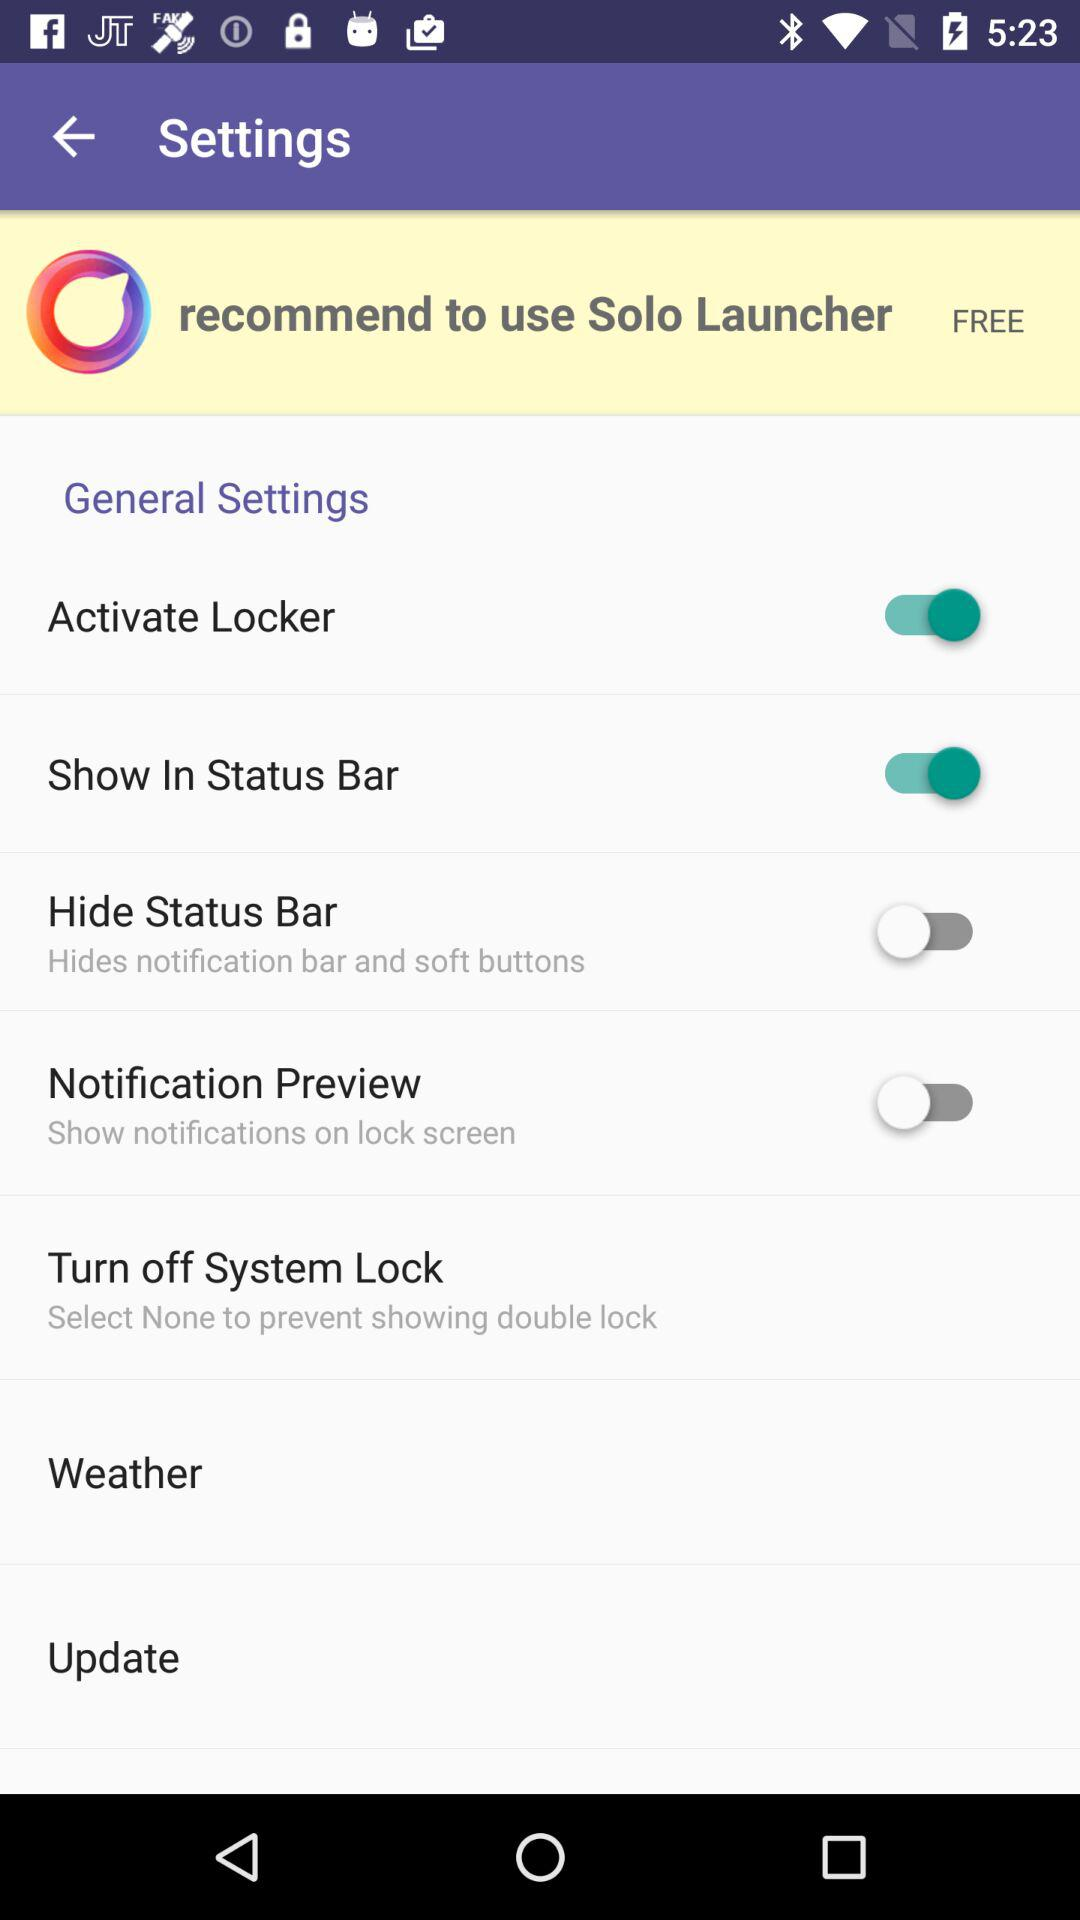What is the status of the "Hide Status Bar"? The status is "off". 